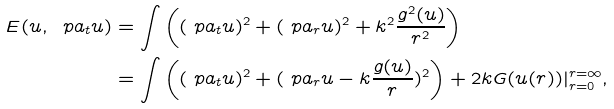Convert formula to latex. <formula><loc_0><loc_0><loc_500><loc_500>E ( u , \ p a _ { t } u ) & = \int \left ( ( \ p a _ { t } u ) ^ { 2 } + ( \ p a _ { r } u ) ^ { 2 } + k ^ { 2 } \frac { g ^ { 2 } ( u ) } { r ^ { 2 } } \right ) \\ & = \int \left ( ( \ p a _ { t } u ) ^ { 2 } + ( \ p a _ { r } u - k \frac { g ( u ) } r ) ^ { 2 } \right ) + 2 k G ( u ( r ) ) | _ { r = 0 } ^ { r = \infty } ,</formula> 